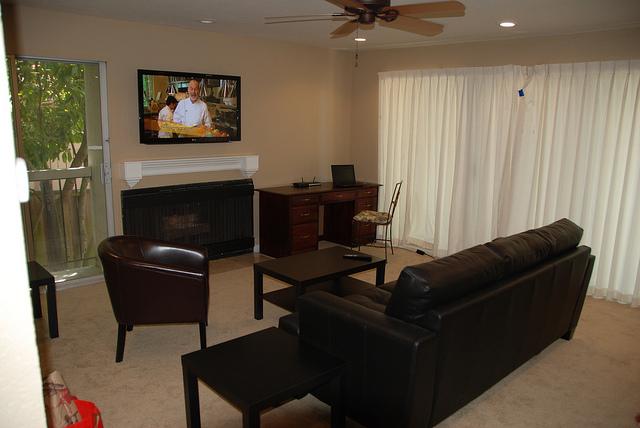What color is the sofa?
Keep it brief. Black. What color are the couch pillows?
Quick response, please. Black. Can this room be used for entertainment?
Write a very short answer. Yes. How many chairs are pictured at the table?
Concise answer only. 1. What color are the walls?
Keep it brief. Tan. What is in the center of the table?
Write a very short answer. Remote. Are the curtains closed?
Quick response, please. Yes. What material is the chair made of?
Keep it brief. Leather. Where could the remote control be?
Short answer required. Table. Do you like watching the show being projected?
Keep it brief. No. How many throw pillows are on the sofa?
Keep it brief. 0. Is there a bedside table in the photo?
Concise answer only. No. What's on the chair?
Short answer required. Nothing. What area of the house is this?
Write a very short answer. Living room. Is there a tv on the wall?
Write a very short answer. Yes. Are there stripes in the image?
Write a very short answer. No. What color are the curtains?
Be succinct. White. Are there any vases in the room?
Answer briefly. No. 